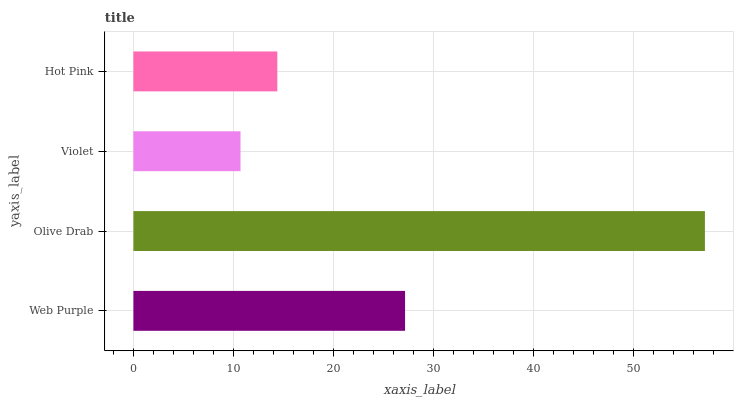Is Violet the minimum?
Answer yes or no. Yes. Is Olive Drab the maximum?
Answer yes or no. Yes. Is Olive Drab the minimum?
Answer yes or no. No. Is Violet the maximum?
Answer yes or no. No. Is Olive Drab greater than Violet?
Answer yes or no. Yes. Is Violet less than Olive Drab?
Answer yes or no. Yes. Is Violet greater than Olive Drab?
Answer yes or no. No. Is Olive Drab less than Violet?
Answer yes or no. No. Is Web Purple the high median?
Answer yes or no. Yes. Is Hot Pink the low median?
Answer yes or no. Yes. Is Olive Drab the high median?
Answer yes or no. No. Is Web Purple the low median?
Answer yes or no. No. 